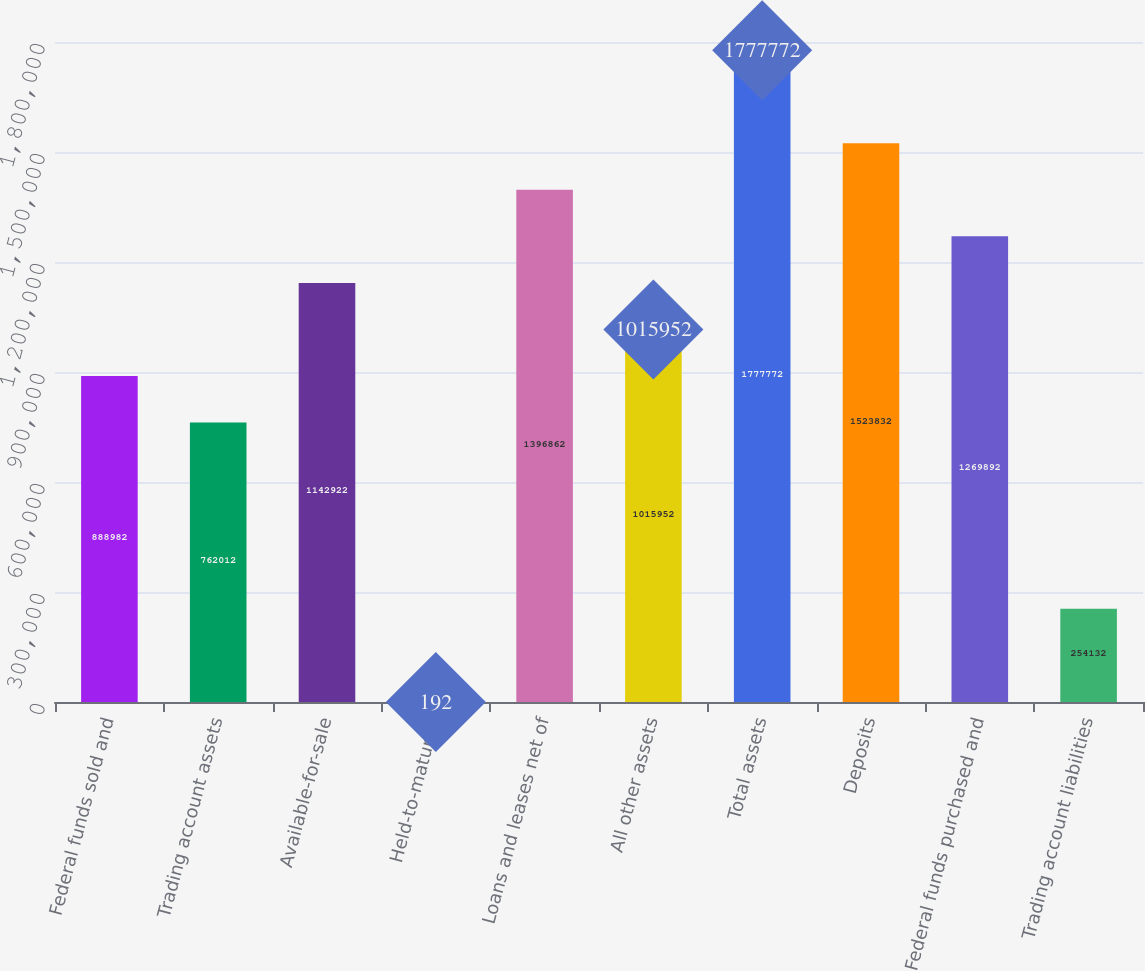Convert chart to OTSL. <chart><loc_0><loc_0><loc_500><loc_500><bar_chart><fcel>Federal funds sold and<fcel>Trading account assets<fcel>Available-for-sale<fcel>Held-to-maturity<fcel>Loans and leases net of<fcel>All other assets<fcel>Total assets<fcel>Deposits<fcel>Federal funds purchased and<fcel>Trading account liabilities<nl><fcel>888982<fcel>762012<fcel>1.14292e+06<fcel>192<fcel>1.39686e+06<fcel>1.01595e+06<fcel>1.77777e+06<fcel>1.52383e+06<fcel>1.26989e+06<fcel>254132<nl></chart> 